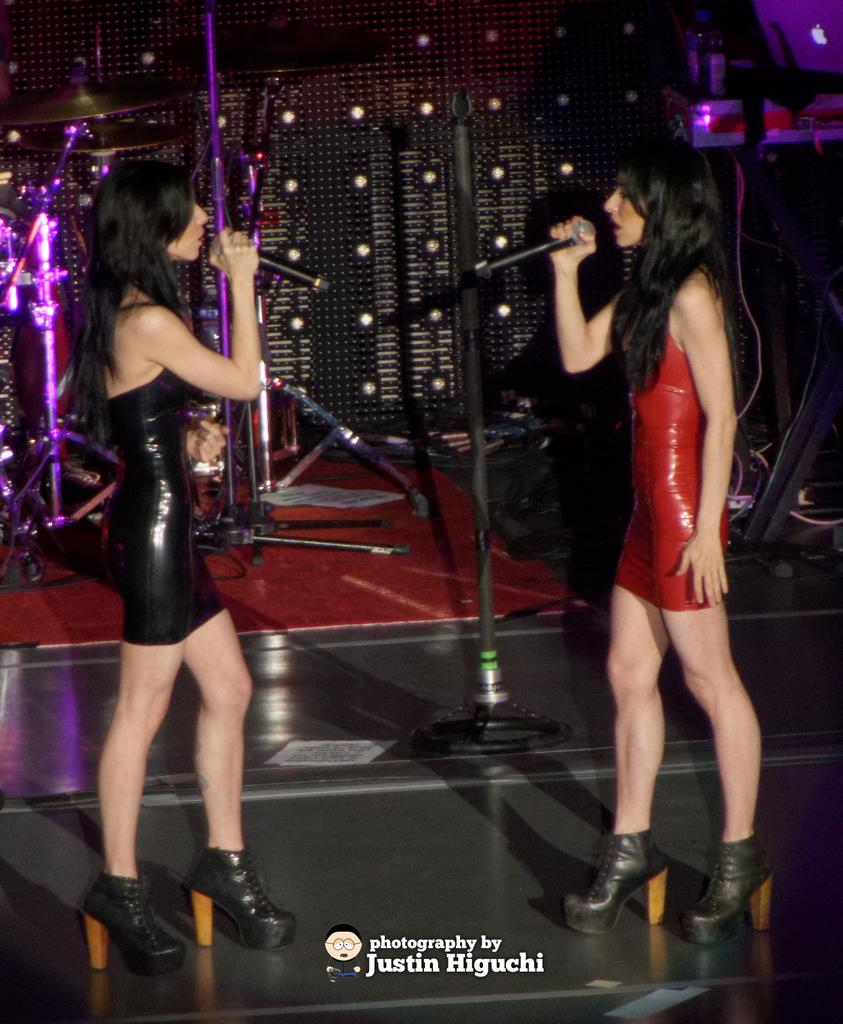How many people are in the image? There are two women in the image. What are the women doing in the image? The women are standing and holding microphones. What can be seen in the background of the image? There are poles and lights in the background of the image. What type of knot is being tied by one of the women in the image? There is no knot-tying activity depicted in the image; the women are holding microphones. Can you tell me how many hydrants are visible in the image? There are no hydrants present in the image. 